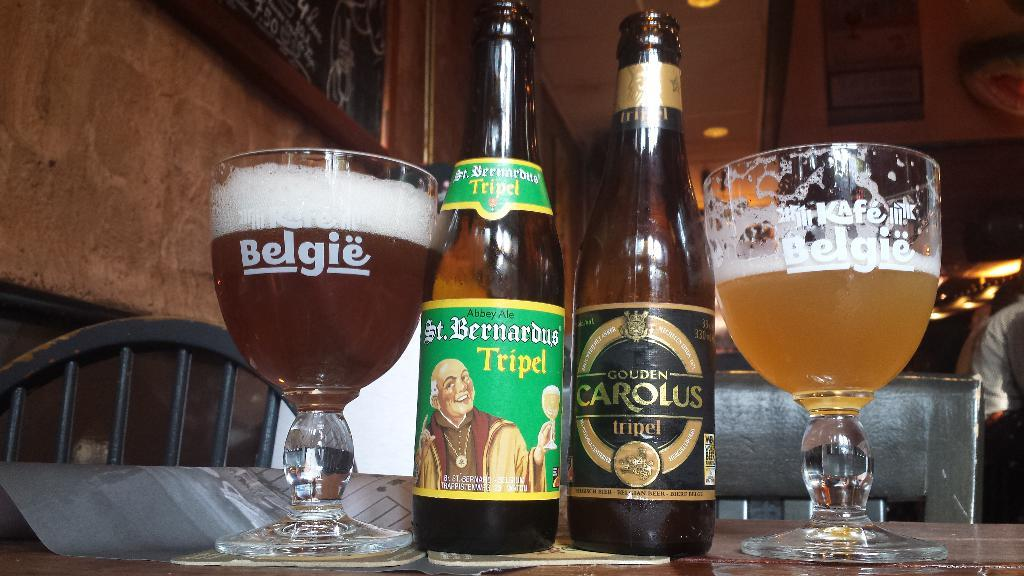<image>
Offer a succinct explanation of the picture presented. A beer bottle of St. Bernardus Tripel and Golden Carolus Tripel with two beer goblets labeled Belgie with the ales poured into them are side by side. 